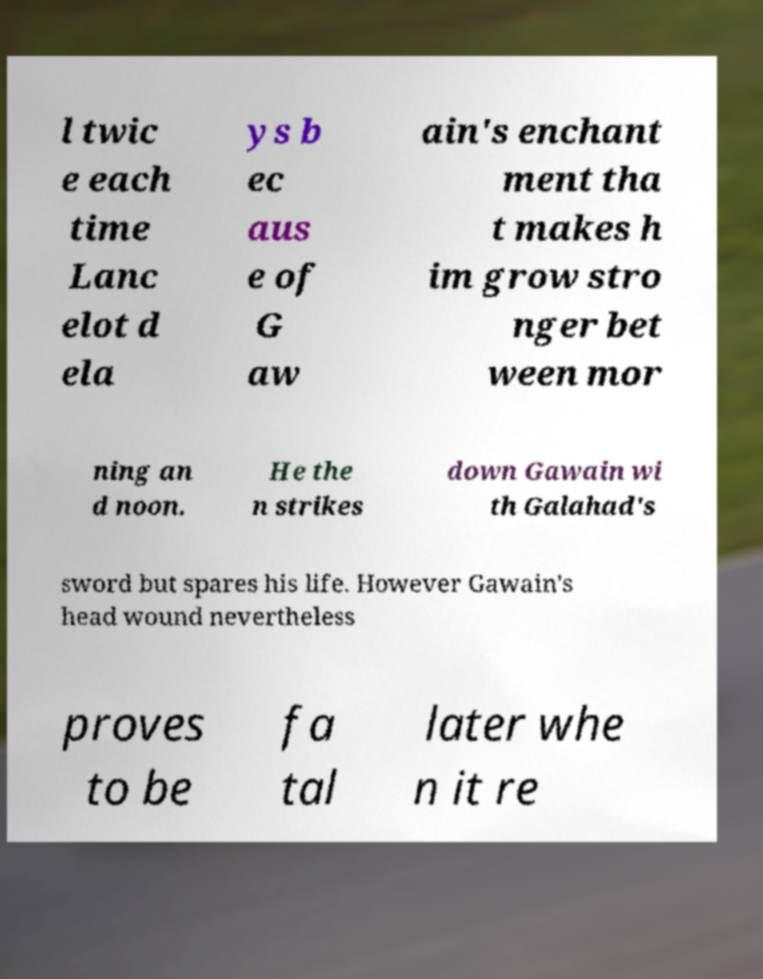Can you read and provide the text displayed in the image?This photo seems to have some interesting text. Can you extract and type it out for me? l twic e each time Lanc elot d ela ys b ec aus e of G aw ain's enchant ment tha t makes h im grow stro nger bet ween mor ning an d noon. He the n strikes down Gawain wi th Galahad's sword but spares his life. However Gawain's head wound nevertheless proves to be fa tal later whe n it re 